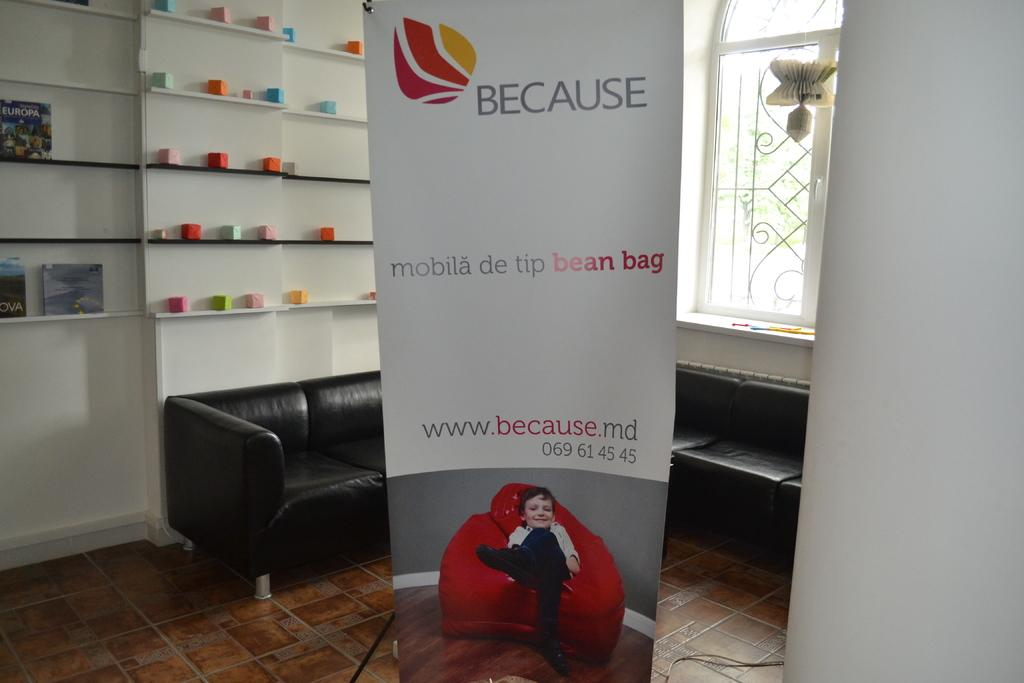What is hanging or displayed in the image? There is a banner in the image. What type of furniture is present in the image? There is a couch in the image. What allows natural light to enter the room in the image? There is a window in the image. What can be used for storage or display in the image? There is a shelf with objects in the image. Can you spot a grape on the couch in the image? There is no grape present on the couch in the image. How does the banner look in the image? The appearance of the banner can be described based on the image, but it does not involve the word "look" in the question. 